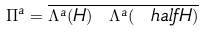Convert formula to latex. <formula><loc_0><loc_0><loc_500><loc_500>\Pi ^ { a } = \overline { \Lambda ^ { a } ( H ) \ \Lambda ^ { a } ( \ h a l f H ) }</formula> 